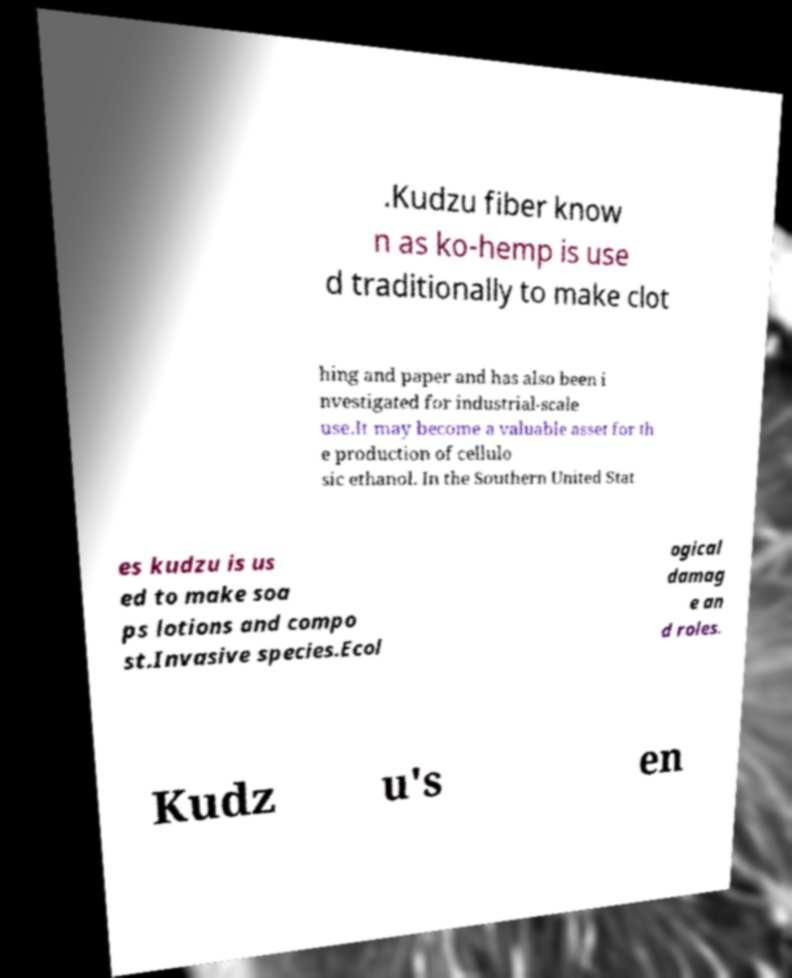Please read and relay the text visible in this image. What does it say? .Kudzu fiber know n as ko-hemp is use d traditionally to make clot hing and paper and has also been i nvestigated for industrial-scale use.It may become a valuable asset for th e production of cellulo sic ethanol. In the Southern United Stat es kudzu is us ed to make soa ps lotions and compo st.Invasive species.Ecol ogical damag e an d roles. Kudz u's en 